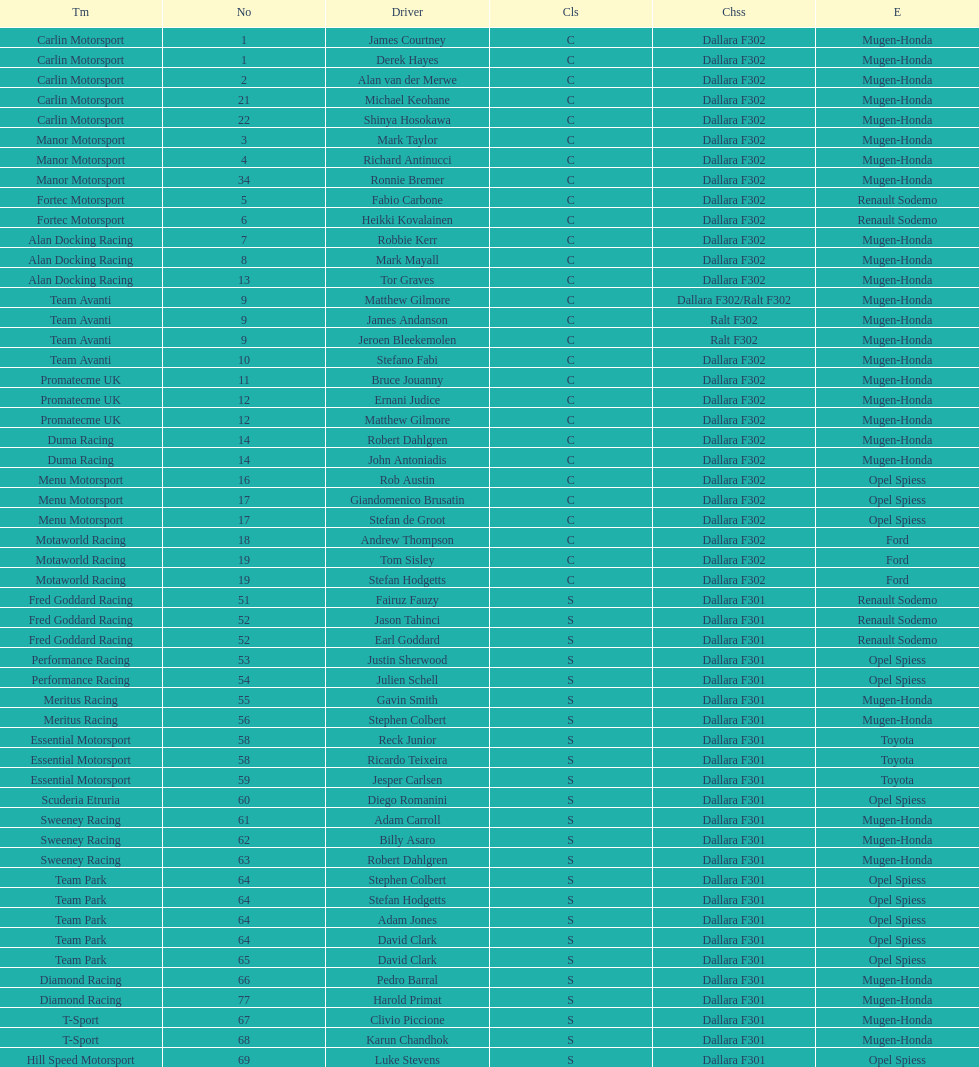What is the total number of class c (championship) teams? 21. 